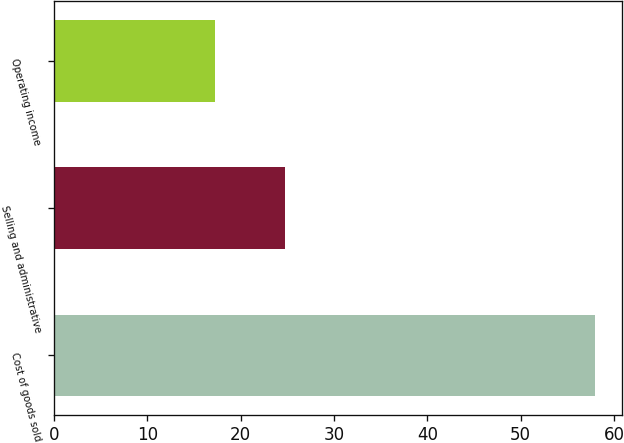Convert chart to OTSL. <chart><loc_0><loc_0><loc_500><loc_500><bar_chart><fcel>Cost of goods sold<fcel>Selling and administrative<fcel>Operating income<nl><fcel>58<fcel>24.7<fcel>17.3<nl></chart> 